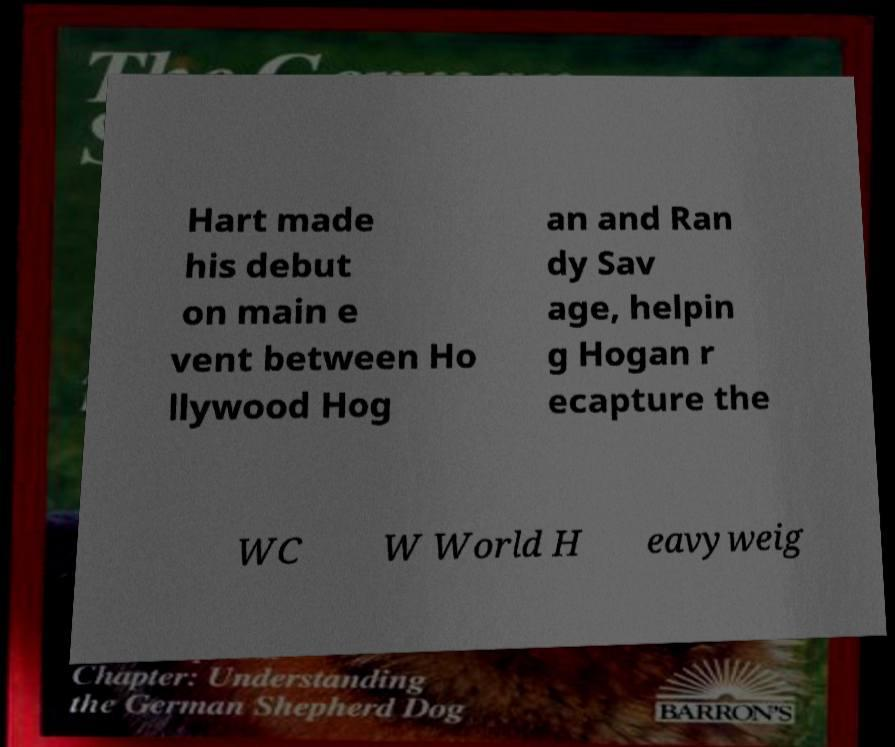Can you accurately transcribe the text from the provided image for me? Hart made his debut on main e vent between Ho llywood Hog an and Ran dy Sav age, helpin g Hogan r ecapture the WC W World H eavyweig 